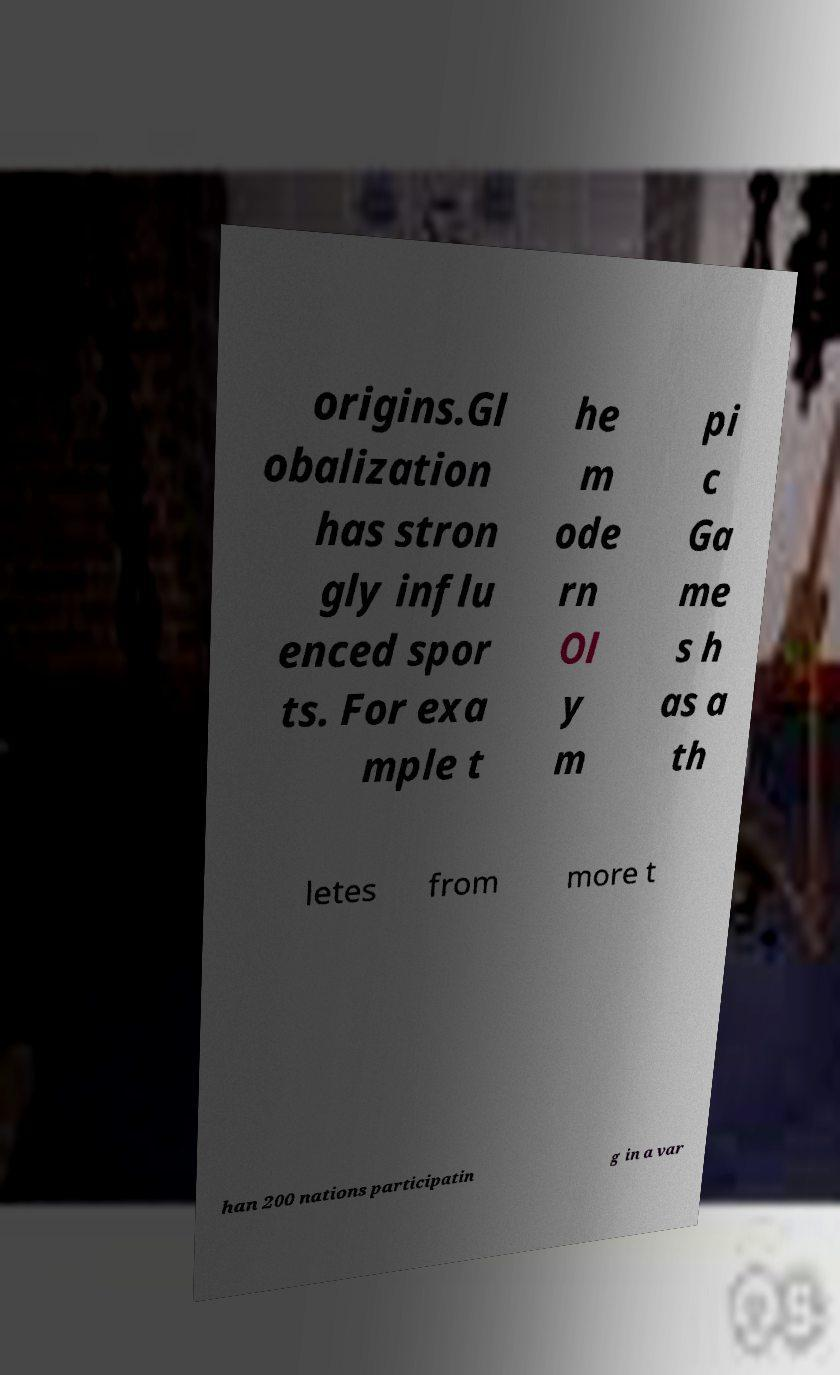What messages or text are displayed in this image? I need them in a readable, typed format. origins.Gl obalization has stron gly influ enced spor ts. For exa mple t he m ode rn Ol y m pi c Ga me s h as a th letes from more t han 200 nations participatin g in a var 